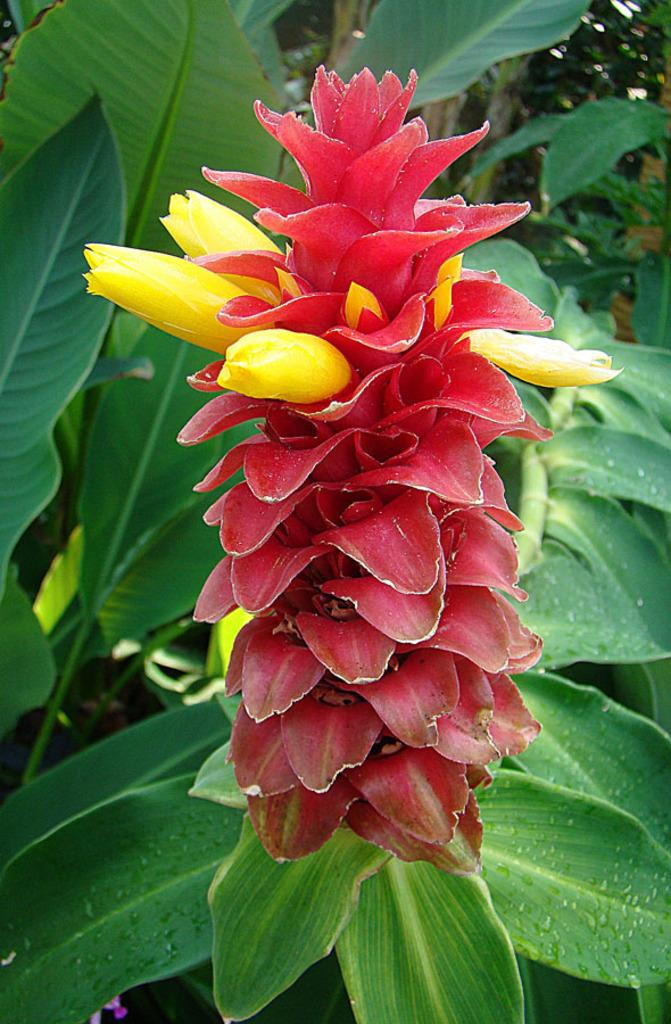What type of living organism is present in the image? There is a plant in the image. What specific feature of the plant can be observed? The plant has flowers. What can be seen in the background of the image? There are trees in the background of the image. What type of card is being used to protect the plant from the rain in the image? There is no card or rain present in the image, and therefore no such protection is needed for the plant. 